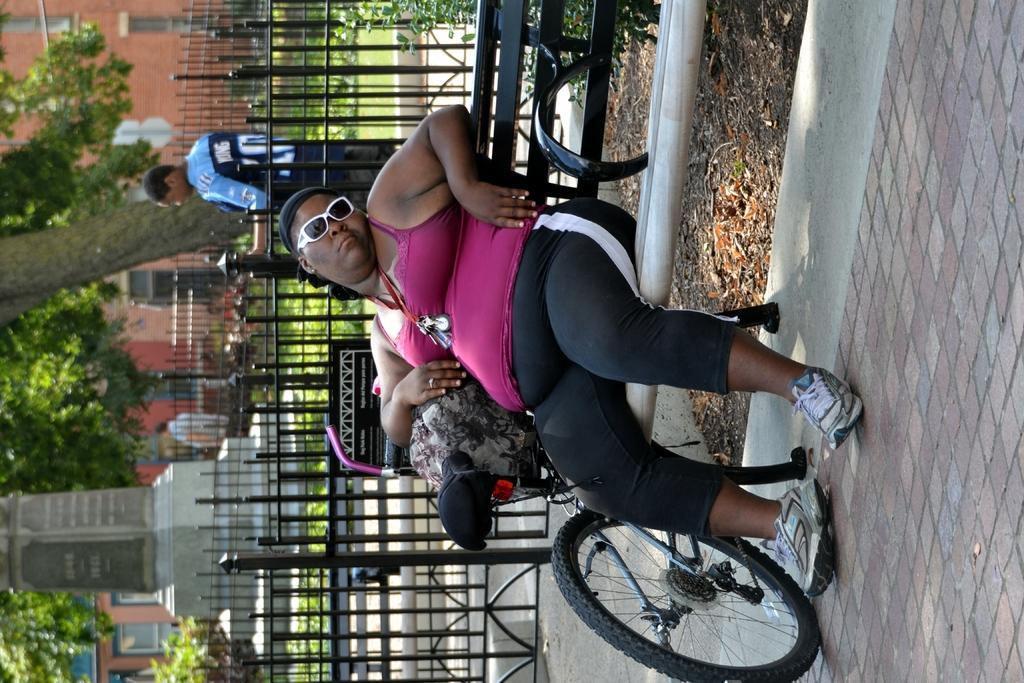Please provide a concise description of this image. In this image we can see a person sitting on the bench, beside the person there is a cycle and an object on the cycle, there is an iron railing with a board to it and a person is standing near the railing, there are few trees, a pillar with text and a building in the background. 